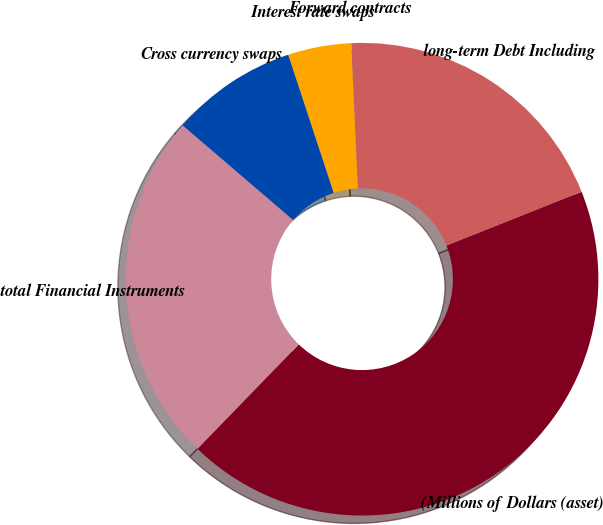<chart> <loc_0><loc_0><loc_500><loc_500><pie_chart><fcel>(Millions of Dollars (asset)<fcel>long-term Debt Including<fcel>Forward contracts<fcel>Interest rate swaps<fcel>Cross currency swaps<fcel>total Financial Instruments<nl><fcel>43.29%<fcel>19.7%<fcel>0.0%<fcel>4.33%<fcel>8.66%<fcel>24.02%<nl></chart> 